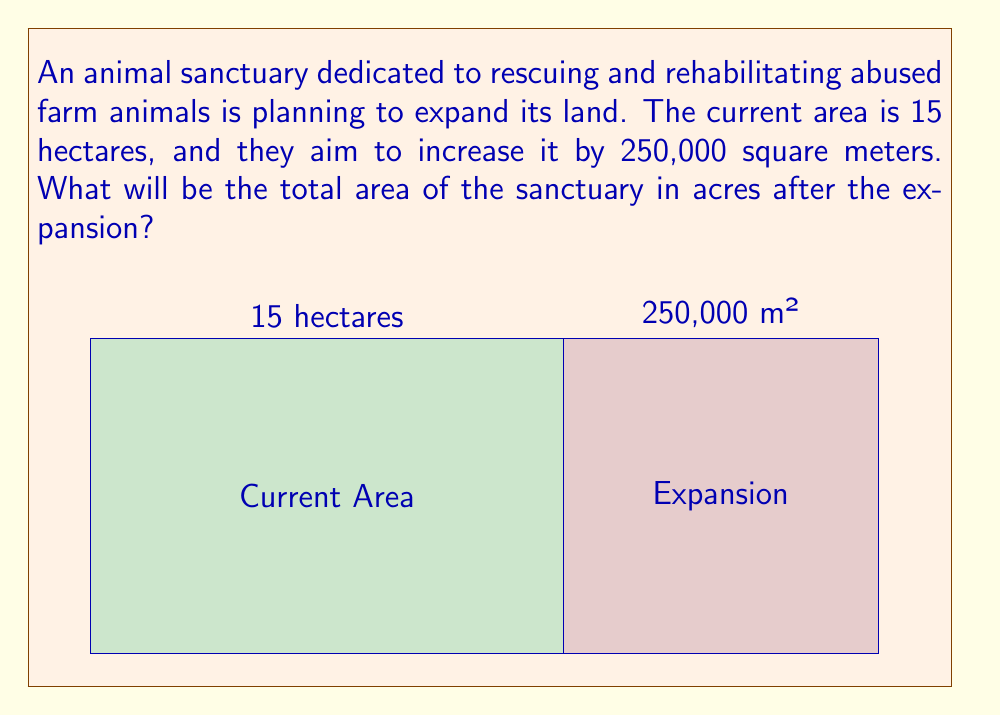Can you answer this question? Let's approach this problem step-by-step:

1) First, we need to convert all measurements to the same unit. Let's use hectares.
   - Current area: 15 hectares
   - Expansion area: 250,000 m² = 25 hectares (since 1 hectare = 10,000 m²)

2) Calculate the total area in hectares:
   $$ 15 \text{ ha} + 25 \text{ ha} = 40 \text{ ha} $$

3) Now, we need to convert hectares to acres:
   - 1 hectare = 2.47105 acres

4) Convert 40 hectares to acres:
   $$ 40 \text{ ha} \times 2.47105 \text{ acres/ha} = 98.842 \text{ acres} $$

5) Rounding to two decimal places:
   $$ 98.84 \text{ acres} $$

This expansion will provide more space for rescued animals to roam freely and live in a more natural environment, aligning with ethical treatment principles.
Answer: 98.84 acres 